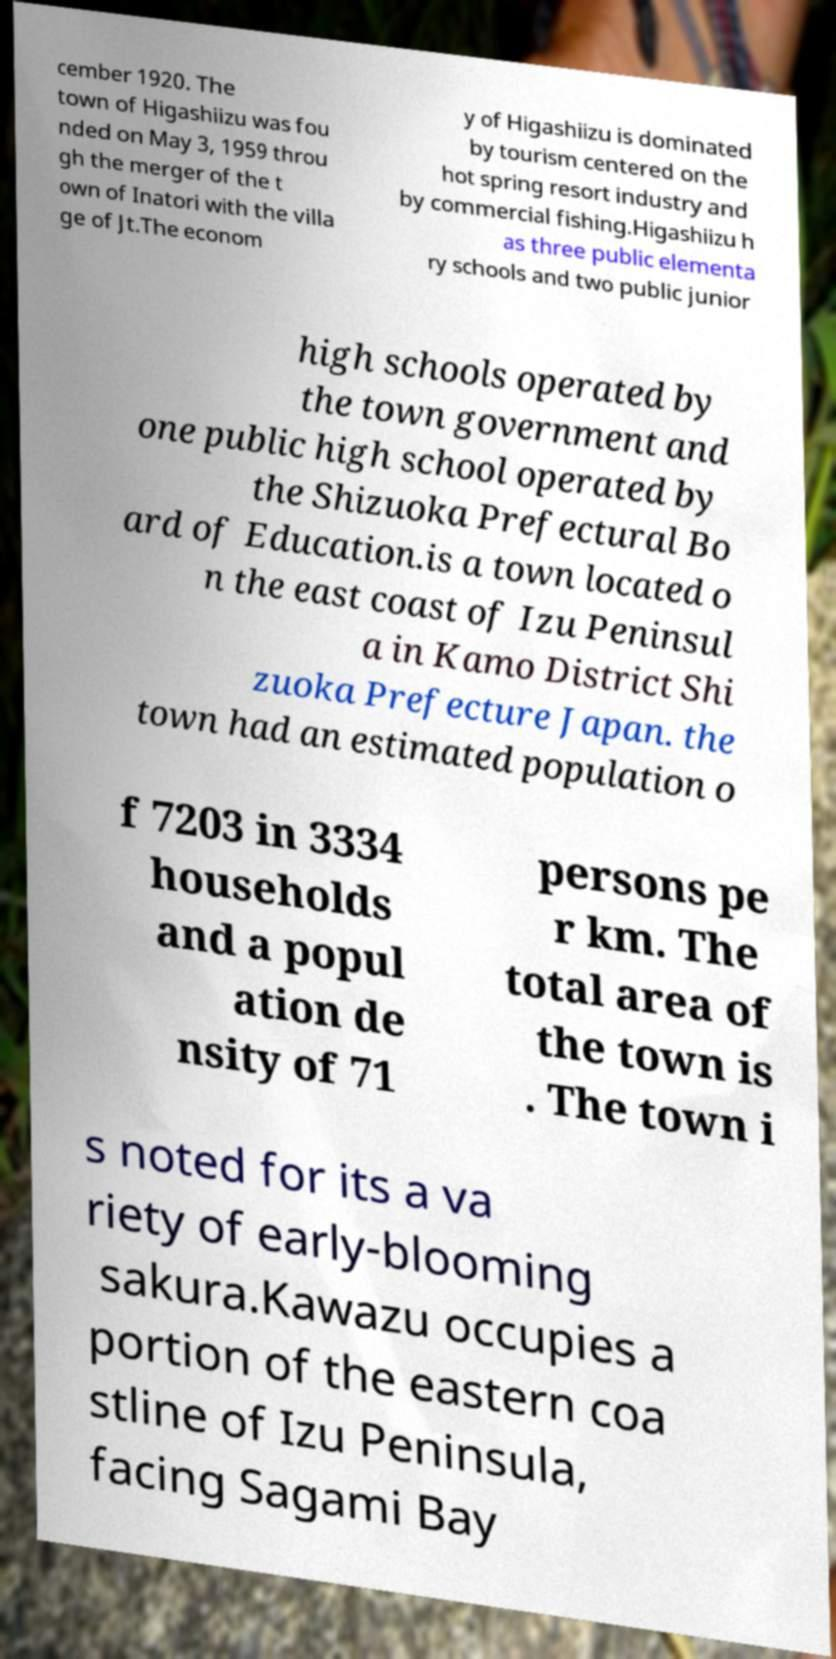I need the written content from this picture converted into text. Can you do that? cember 1920. The town of Higashiizu was fou nded on May 3, 1959 throu gh the merger of the t own of Inatori with the villa ge of Jt.The econom y of Higashiizu is dominated by tourism centered on the hot spring resort industry and by commercial fishing.Higashiizu h as three public elementa ry schools and two public junior high schools operated by the town government and one public high school operated by the Shizuoka Prefectural Bo ard of Education.is a town located o n the east coast of Izu Peninsul a in Kamo District Shi zuoka Prefecture Japan. the town had an estimated population o f 7203 in 3334 households and a popul ation de nsity of 71 persons pe r km. The total area of the town is . The town i s noted for its a va riety of early-blooming sakura.Kawazu occupies a portion of the eastern coa stline of Izu Peninsula, facing Sagami Bay 